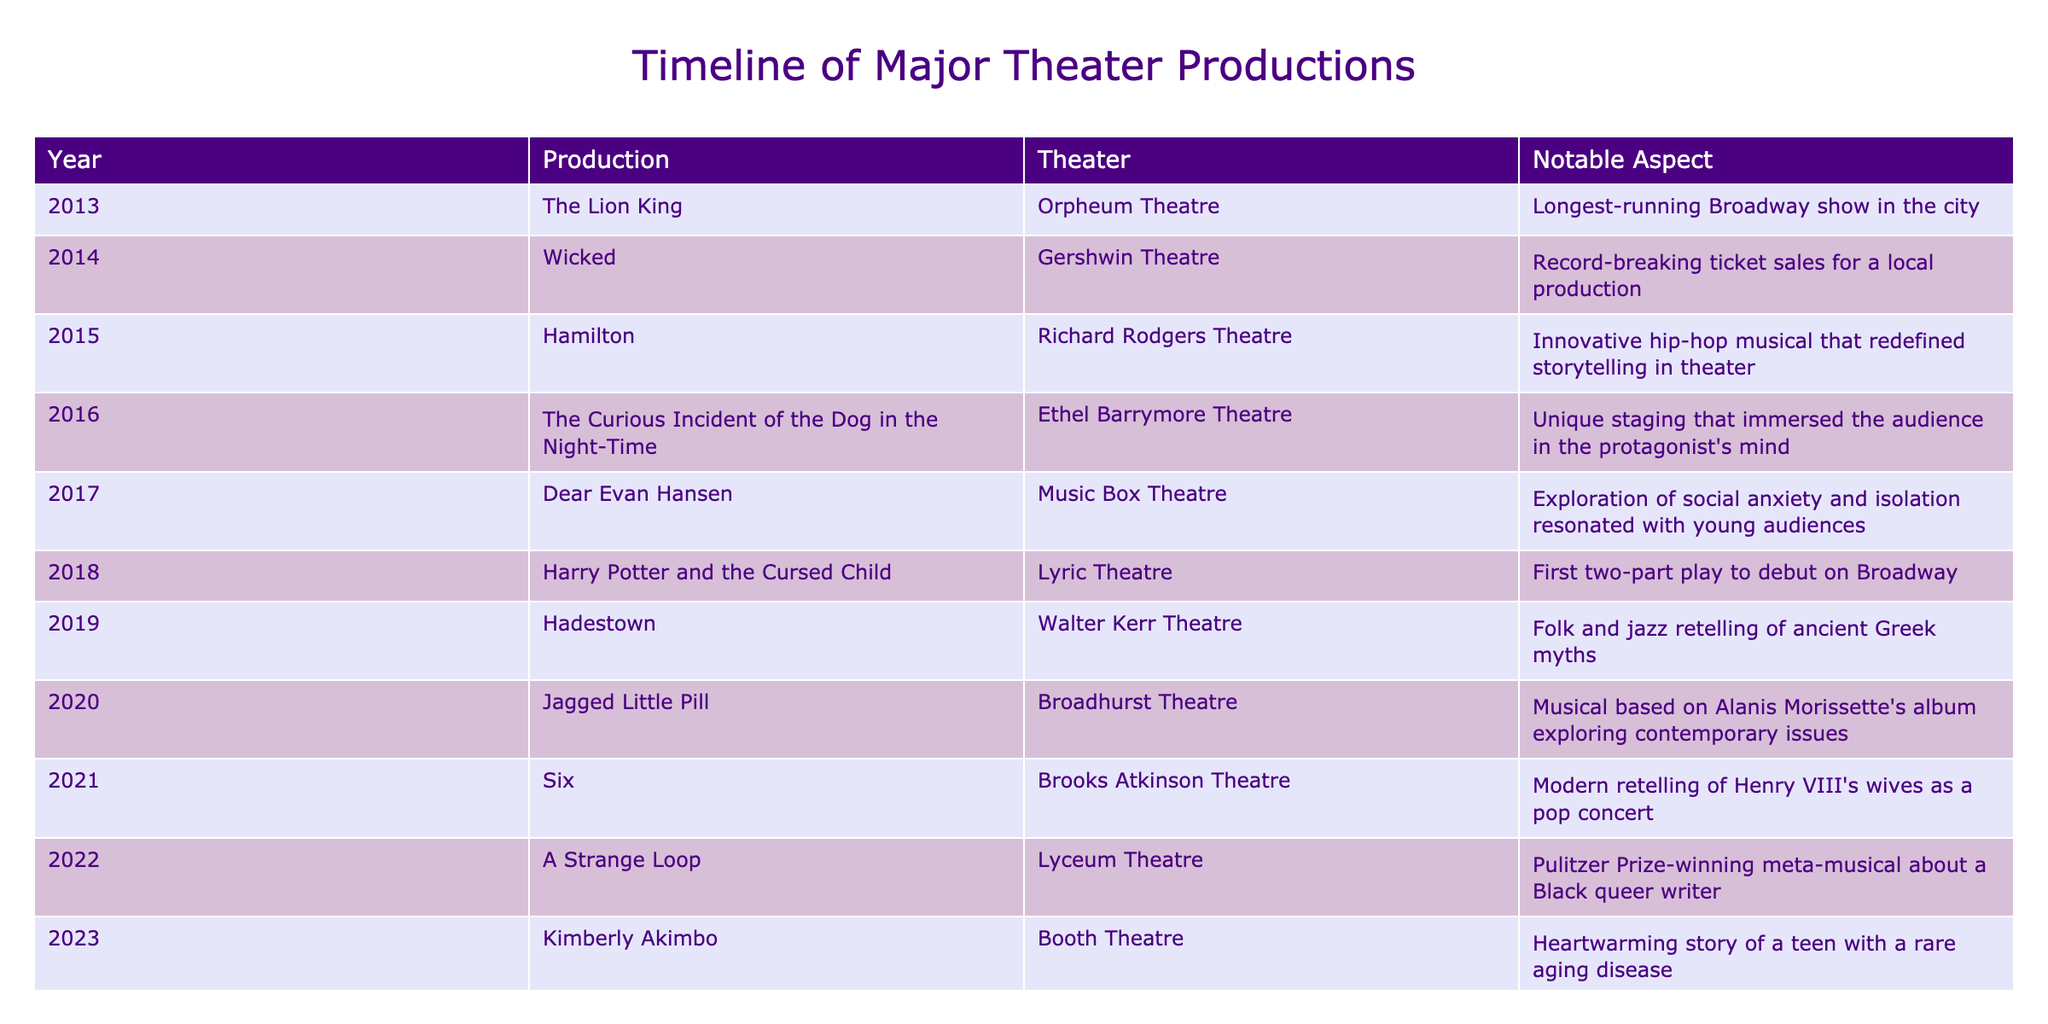What was the notable aspect of "Hamilton"? The table indicates that "Hamilton" was recognized for its innovative hip-hop musical style that redefined storytelling in theater. This information is explicitly listed in the "Notable Aspect" column corresponding to the year it was produced.
Answer: Innovative hip-hop musical that redefined storytelling in theater Which theater hosted the production of "Dear Evan Hansen"? By looking at the "Theater" column for the row corresponding to "Dear Evan Hansen," we can see that it was hosted at the Music Box Theatre. This is a straightforward retrieval of information from the table.
Answer: Music Box Theatre How many productions were staged in the year 2020 and 2021 combined? Referring to the table, "Jagged Little Pill" was staged in 2020 and "Six" was staged in 2021, so by counting these, we find there were 2 productions in those two years. This requires a simple addition, where we identify each year and the corresponding values.
Answer: 2 Which production had record-breaking ticket sales? The table specifies that "Wicked," produced in 2014, had record-breaking ticket sales for a local production. This information is directly retrievable from the "Notable Aspect" column for that specific year.
Answer: Wicked Was "Harry Potter and the Cursed Child" a standalone play? The information in the table states it was the first two-part play to debut on Broadway. Therefore, this indicates that it is not a standalone production, as it consists of two parts.
Answer: No What production had a notable aspect concerning social issues? The table shows that "Jagged Little Pill," staged in 2020, was based on Alanis Morissette's album and explored contemporary issues. Finding this in the "Notable Aspect" column provides the needed information.
Answer: Jagged Little Pill In what year was the production "A Strange Loop" launched and what notable award did it receive? The table indicates that "A Strange Loop" was launched in 2022 and won the Pulitzer Prize. To answer this, we read through the row for the production to confirm both the year and the notable aspect mentioned in the table.
Answer: 2022, Pulitzer Prize Which theater hosted the most recent production listed in the table? The last production in the table is "Kimberly Akimbo," which, according to the "Theater" column, was hosted at the Booth Theatre. This can easily be pinpointed by locating the last entry in the table and reading its corresponding theater name.
Answer: Booth Theatre 